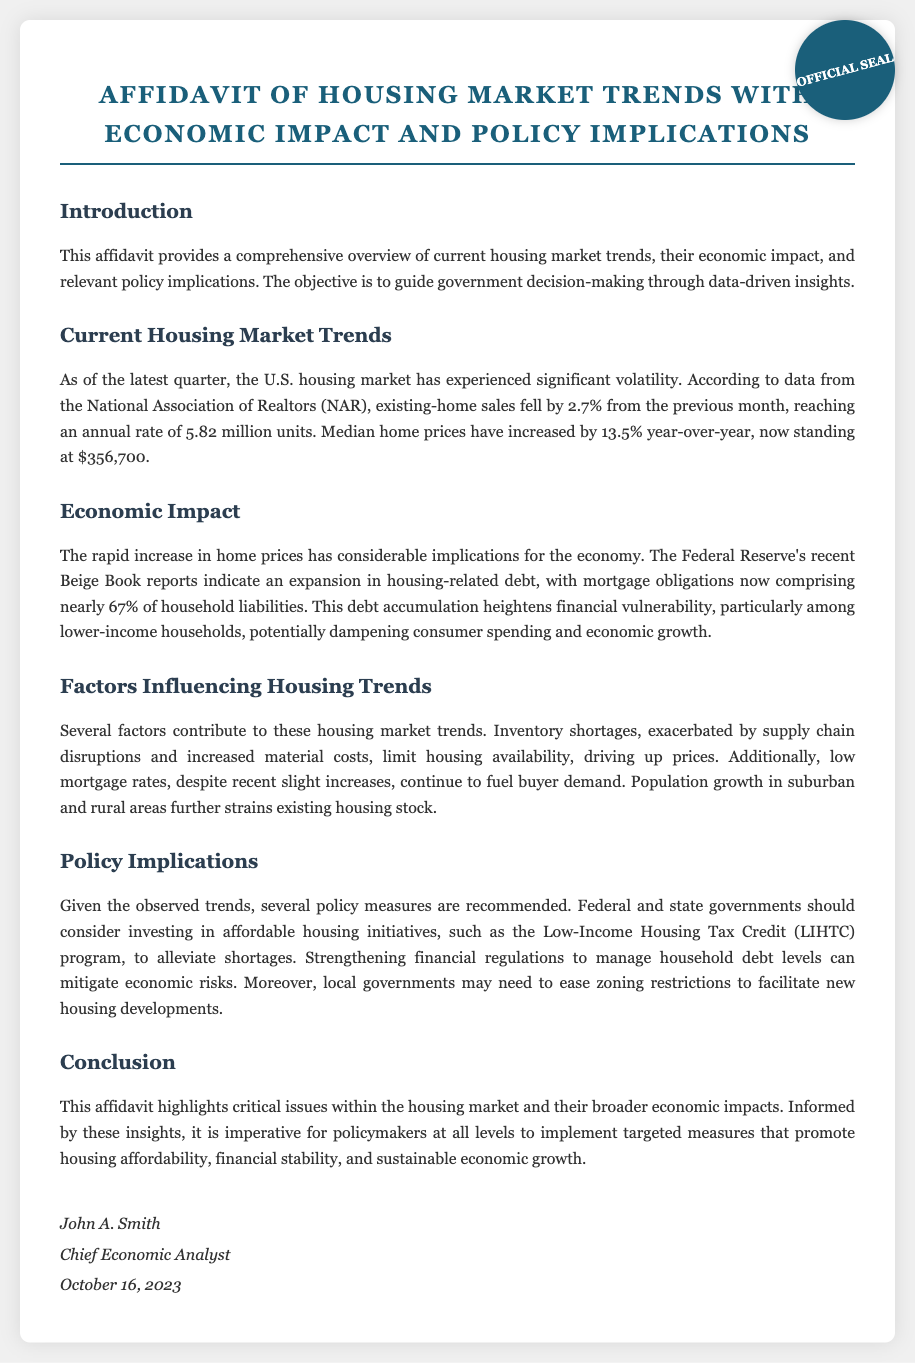what is the annual rate of existing-home sales? The current annual rate of existing-home sales as reported is 5.82 million units.
Answer: 5.82 million units what is the percentage increase in median home prices year-over-year? The document states that median home prices have increased by 13.5% year-over-year.
Answer: 13.5% who is the Chief Economic Analyst? The Chief Economic Analyst's name mentioned in the affidavit is John A. Smith.
Answer: John A. Smith what percentage of household liabilities does mortgage obligations comprise? According to the affidavit, mortgage obligations now comprise nearly 67% of household liabilities.
Answer: 67% what is one suggested policy measure to address housing shortages? One suggested policy measure to address housing shortages is to invest in affordable housing initiatives.
Answer: invest in affordable housing initiatives what is the main reason for the increase in home prices? The main reason for the increase in home prices is inventory shortages exacerbated by supply chain disruptions.
Answer: inventory shortages what date was the affidavit signed? The affidavit was signed on October 16, 2023.
Answer: October 16, 2023 what are the two areas experiencing population growth impacting housing? The two areas experiencing population growth that impact housing are suburban and rural areas.
Answer: suburban and rural areas 